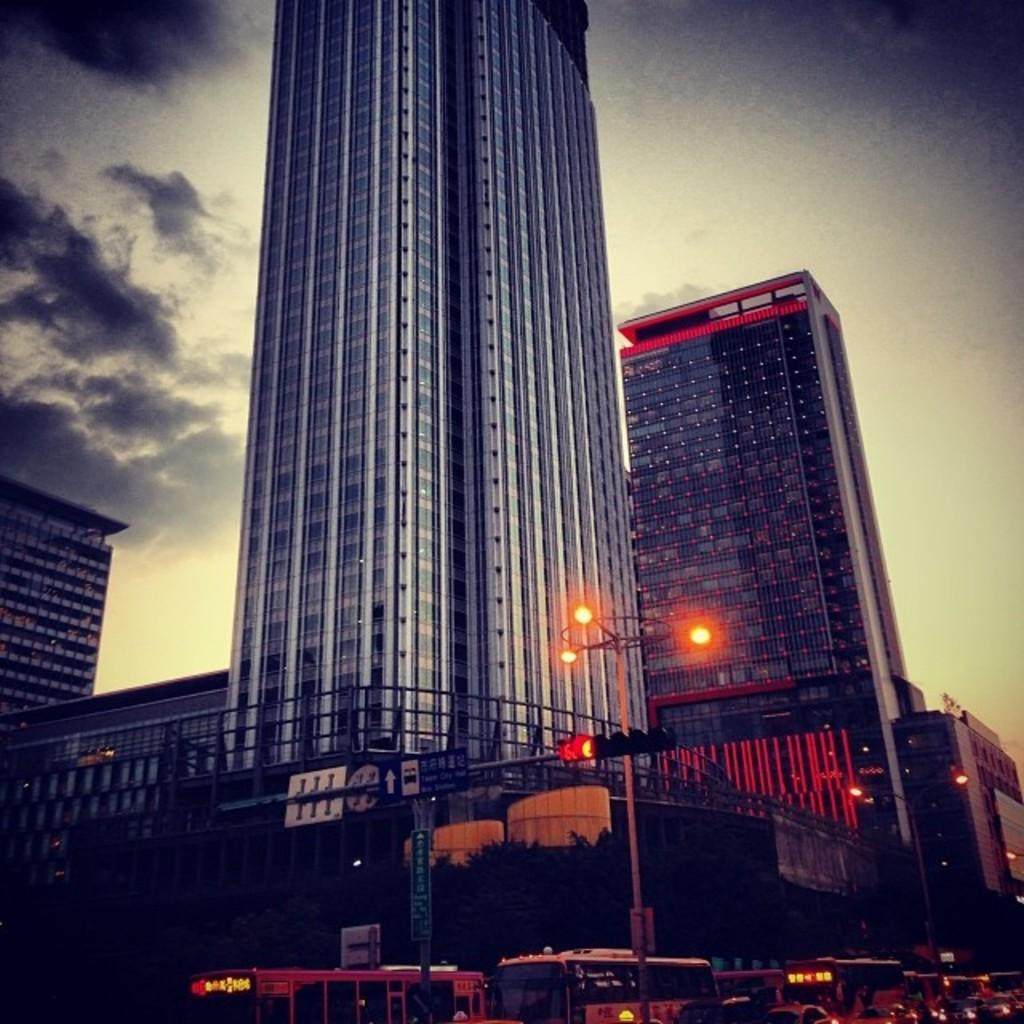What type of structures can be seen in the image? There are many buildings in the image. What else can be seen besides buildings? There are vehicles, poles, boards, and lights visible in the image. Can you describe the sky in the background of the image? The sky is visible in the background of the image, and clouds are present. How many windows can be seen on the tail of the vehicle in the image? There is no vehicle with a tail present in the image, and therefore no windows on a tail can be observed. 